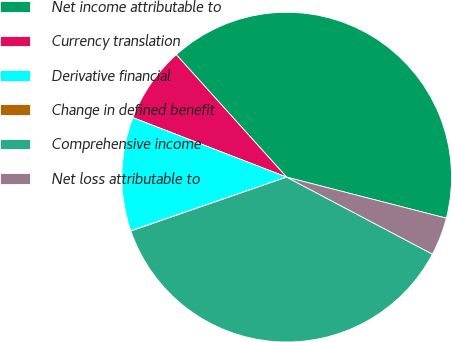Convert chart. <chart><loc_0><loc_0><loc_500><loc_500><pie_chart><fcel>Net income attributable to<fcel>Currency translation<fcel>Derivative financial<fcel>Change in defined benefit<fcel>Comprehensive income<fcel>Net loss attributable to<nl><fcel>40.68%<fcel>7.45%<fcel>11.16%<fcel>0.02%<fcel>36.96%<fcel>3.73%<nl></chart> 